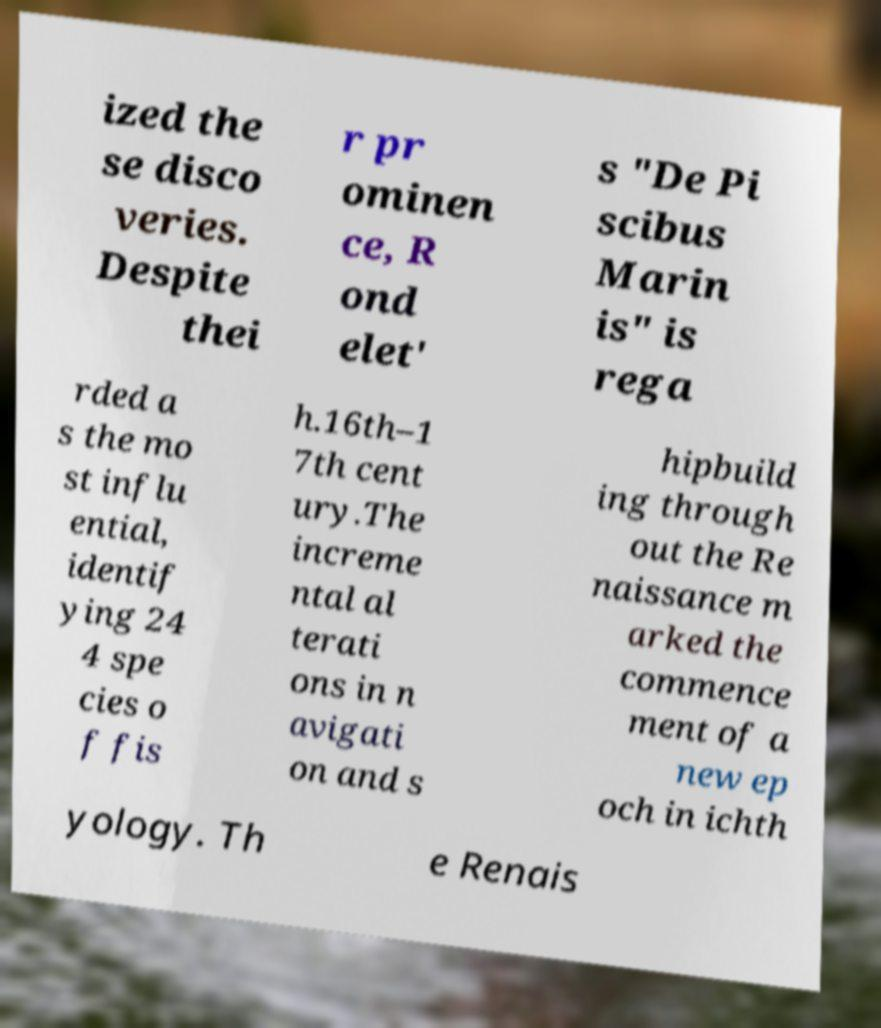What messages or text are displayed in this image? I need them in a readable, typed format. ized the se disco veries. Despite thei r pr ominen ce, R ond elet' s "De Pi scibus Marin is" is rega rded a s the mo st influ ential, identif ying 24 4 spe cies o f fis h.16th–1 7th cent ury.The increme ntal al terati ons in n avigati on and s hipbuild ing through out the Re naissance m arked the commence ment of a new ep och in ichth yology. Th e Renais 